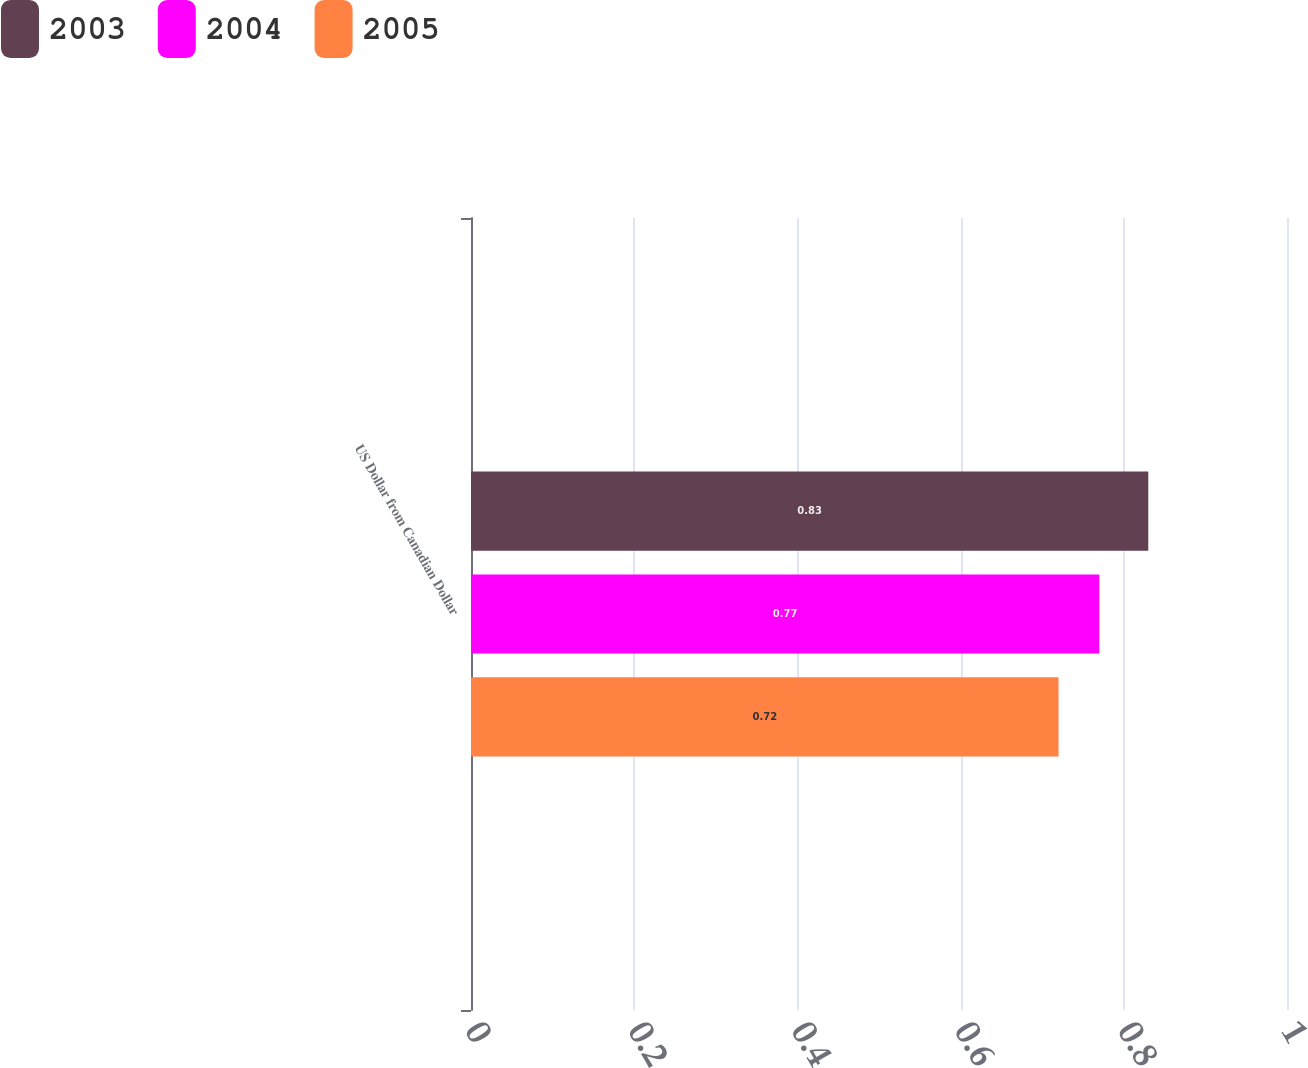Convert chart. <chart><loc_0><loc_0><loc_500><loc_500><stacked_bar_chart><ecel><fcel>US Dollar from Canadian Dollar<nl><fcel>2003<fcel>0.83<nl><fcel>2004<fcel>0.77<nl><fcel>2005<fcel>0.72<nl></chart> 